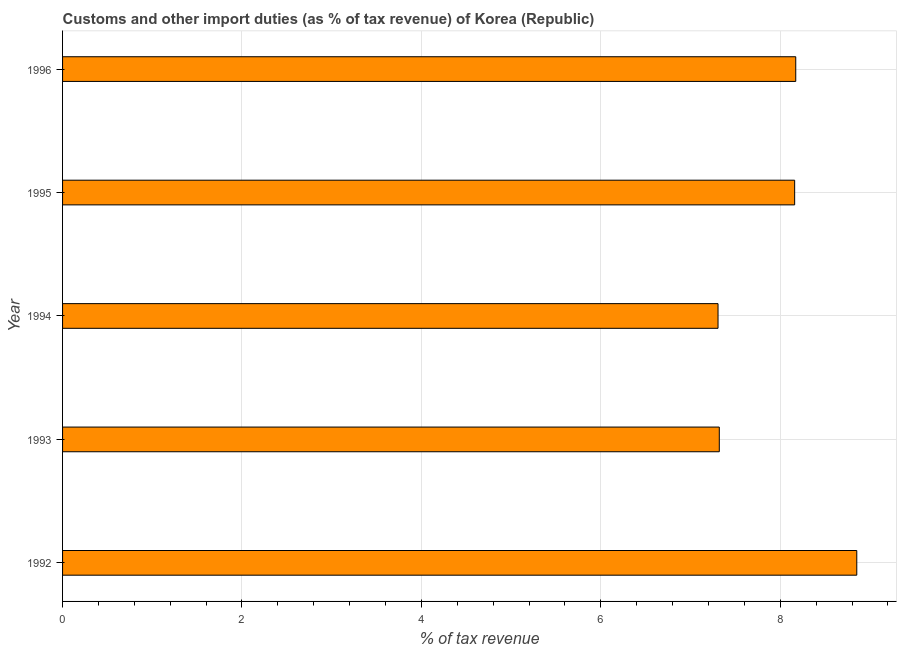Does the graph contain grids?
Give a very brief answer. Yes. What is the title of the graph?
Offer a very short reply. Customs and other import duties (as % of tax revenue) of Korea (Republic). What is the label or title of the X-axis?
Provide a short and direct response. % of tax revenue. What is the label or title of the Y-axis?
Offer a terse response. Year. What is the customs and other import duties in 1996?
Offer a very short reply. 8.17. Across all years, what is the maximum customs and other import duties?
Give a very brief answer. 8.85. Across all years, what is the minimum customs and other import duties?
Your response must be concise. 7.31. In which year was the customs and other import duties minimum?
Your answer should be compact. 1994. What is the sum of the customs and other import duties?
Your answer should be very brief. 39.81. What is the difference between the customs and other import duties in 1993 and 1994?
Your response must be concise. 0.01. What is the average customs and other import duties per year?
Make the answer very short. 7.96. What is the median customs and other import duties?
Provide a succinct answer. 8.16. In how many years, is the customs and other import duties greater than 8 %?
Give a very brief answer. 3. Do a majority of the years between 1992 and 1994 (inclusive) have customs and other import duties greater than 4.8 %?
Offer a very short reply. Yes. What is the ratio of the customs and other import duties in 1994 to that in 1996?
Give a very brief answer. 0.89. What is the difference between the highest and the second highest customs and other import duties?
Ensure brevity in your answer.  0.68. Is the sum of the customs and other import duties in 1994 and 1996 greater than the maximum customs and other import duties across all years?
Offer a very short reply. Yes. What is the difference between the highest and the lowest customs and other import duties?
Your answer should be compact. 1.55. What is the difference between two consecutive major ticks on the X-axis?
Ensure brevity in your answer.  2. Are the values on the major ticks of X-axis written in scientific E-notation?
Ensure brevity in your answer.  No. What is the % of tax revenue of 1992?
Make the answer very short. 8.85. What is the % of tax revenue in 1993?
Ensure brevity in your answer.  7.32. What is the % of tax revenue of 1994?
Provide a short and direct response. 7.31. What is the % of tax revenue in 1995?
Keep it short and to the point. 8.16. What is the % of tax revenue of 1996?
Your answer should be compact. 8.17. What is the difference between the % of tax revenue in 1992 and 1993?
Give a very brief answer. 1.53. What is the difference between the % of tax revenue in 1992 and 1994?
Make the answer very short. 1.55. What is the difference between the % of tax revenue in 1992 and 1995?
Make the answer very short. 0.69. What is the difference between the % of tax revenue in 1992 and 1996?
Keep it short and to the point. 0.68. What is the difference between the % of tax revenue in 1993 and 1994?
Provide a succinct answer. 0.01. What is the difference between the % of tax revenue in 1993 and 1995?
Your answer should be compact. -0.84. What is the difference between the % of tax revenue in 1993 and 1996?
Keep it short and to the point. -0.85. What is the difference between the % of tax revenue in 1994 and 1995?
Provide a succinct answer. -0.85. What is the difference between the % of tax revenue in 1994 and 1996?
Your response must be concise. -0.87. What is the difference between the % of tax revenue in 1995 and 1996?
Your answer should be compact. -0.01. What is the ratio of the % of tax revenue in 1992 to that in 1993?
Your answer should be compact. 1.21. What is the ratio of the % of tax revenue in 1992 to that in 1994?
Give a very brief answer. 1.21. What is the ratio of the % of tax revenue in 1992 to that in 1995?
Your answer should be compact. 1.08. What is the ratio of the % of tax revenue in 1992 to that in 1996?
Your answer should be compact. 1.08. What is the ratio of the % of tax revenue in 1993 to that in 1994?
Your answer should be compact. 1. What is the ratio of the % of tax revenue in 1993 to that in 1995?
Offer a very short reply. 0.9. What is the ratio of the % of tax revenue in 1993 to that in 1996?
Make the answer very short. 0.9. What is the ratio of the % of tax revenue in 1994 to that in 1995?
Keep it short and to the point. 0.9. What is the ratio of the % of tax revenue in 1994 to that in 1996?
Keep it short and to the point. 0.89. 